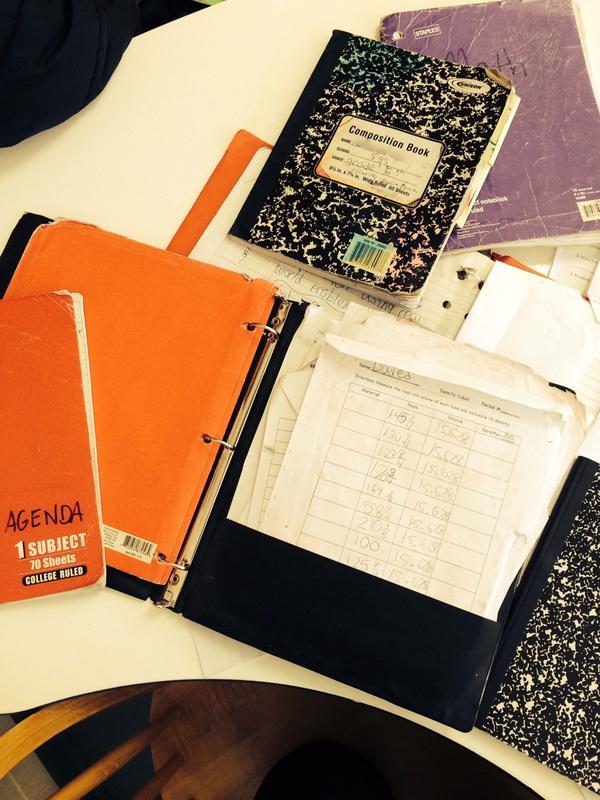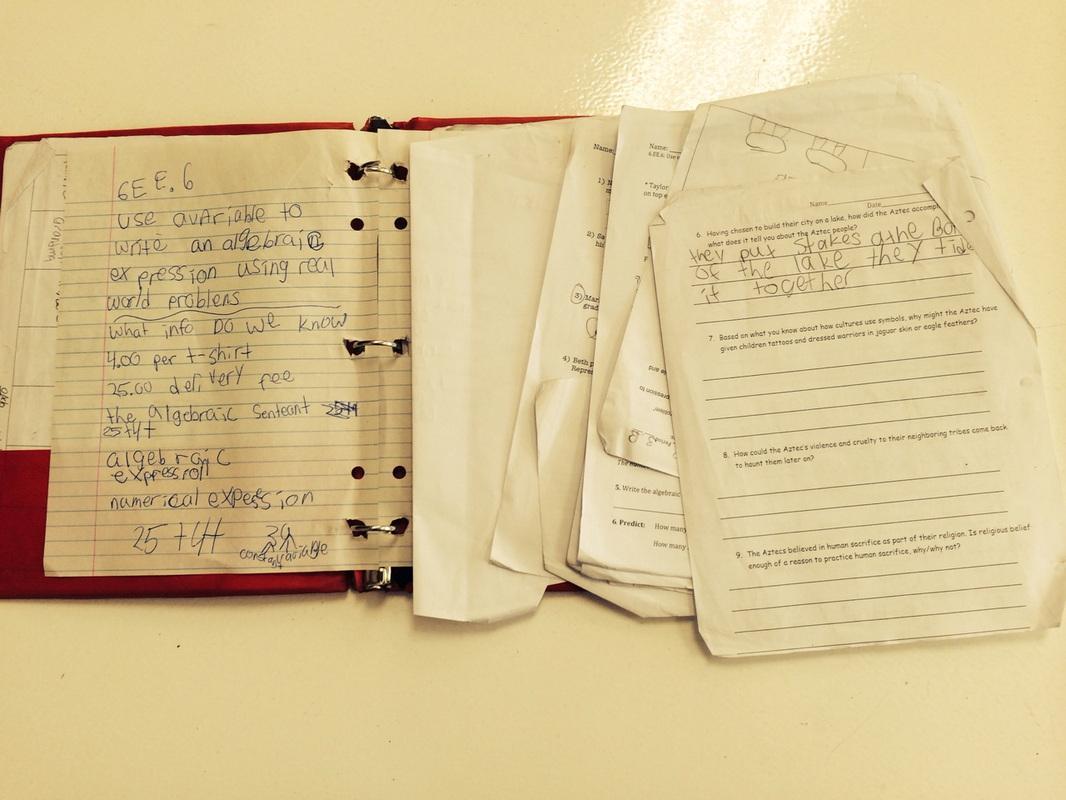The first image is the image on the left, the second image is the image on the right. For the images shown, is this caption "The left image shows only one binder, which is purplish in color." true? Answer yes or no. No. The first image is the image on the left, the second image is the image on the right. For the images displayed, is the sentence "One zipper binder is unzipped and open so that at least one set of three notebook rings and multiple interior pockets are visible." factually correct? Answer yes or no. No. 